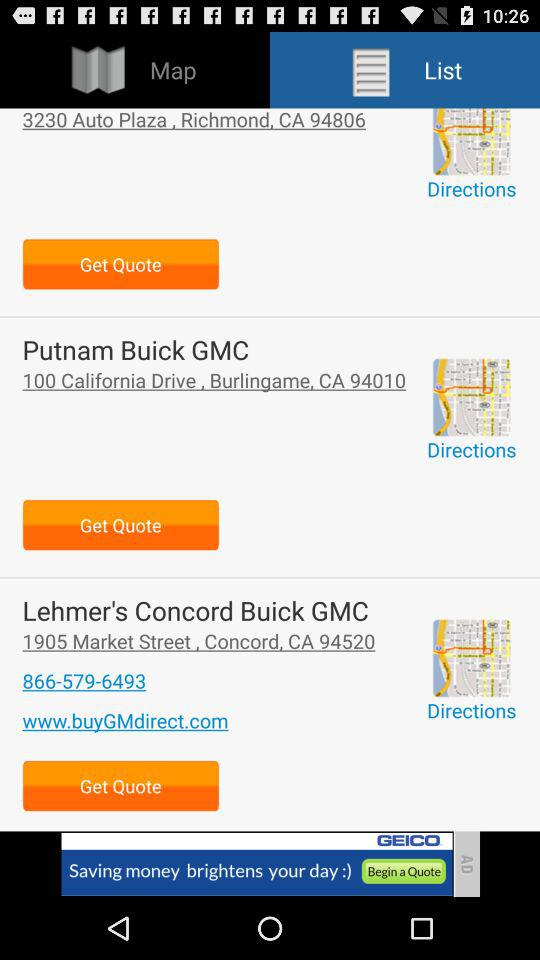How many maps are available?
When the provided information is insufficient, respond with <no answer>. <no answer> 